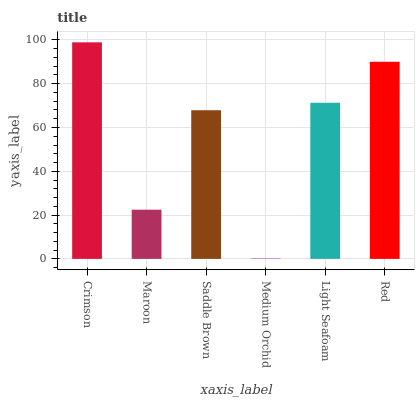Is Maroon the minimum?
Answer yes or no. No. Is Maroon the maximum?
Answer yes or no. No. Is Crimson greater than Maroon?
Answer yes or no. Yes. Is Maroon less than Crimson?
Answer yes or no. Yes. Is Maroon greater than Crimson?
Answer yes or no. No. Is Crimson less than Maroon?
Answer yes or no. No. Is Light Seafoam the high median?
Answer yes or no. Yes. Is Saddle Brown the low median?
Answer yes or no. Yes. Is Saddle Brown the high median?
Answer yes or no. No. Is Red the low median?
Answer yes or no. No. 